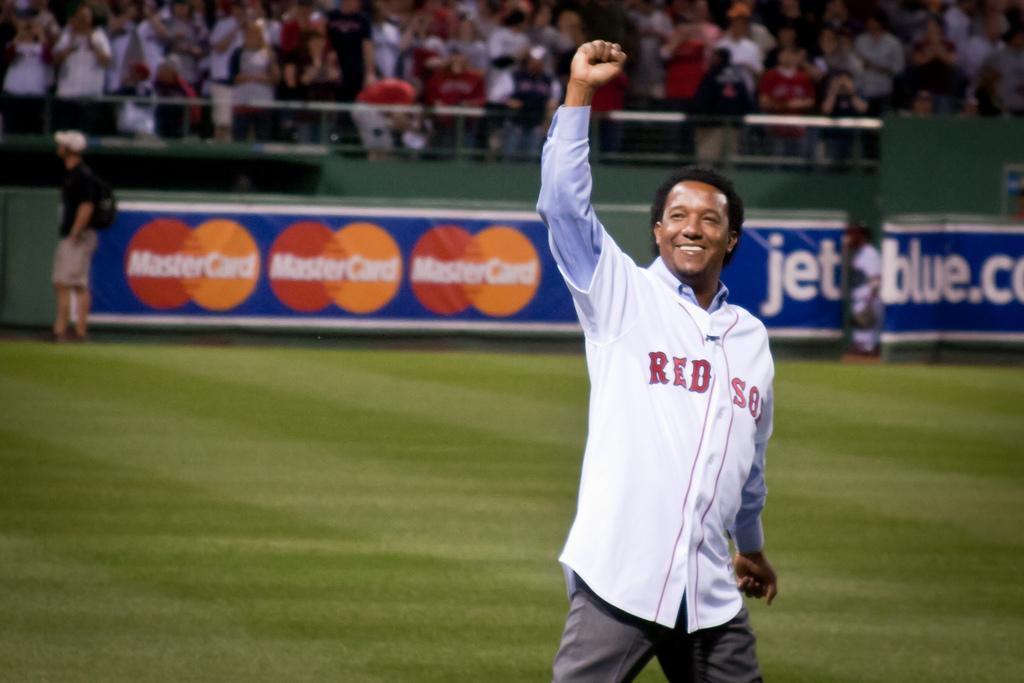What credit card company is displayed on the wall?
Make the answer very short. Mastercard. What team is represented on his jersey?
Offer a terse response. Red sox. 